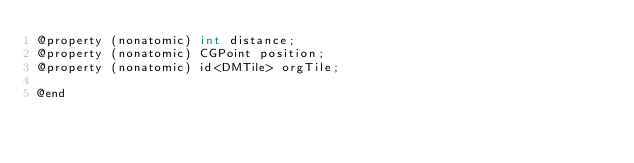<code> <loc_0><loc_0><loc_500><loc_500><_C_>@property (nonatomic) int distance;
@property (nonatomic) CGPoint position;
@property (nonatomic) id<DMTile> orgTile;

@end
</code> 